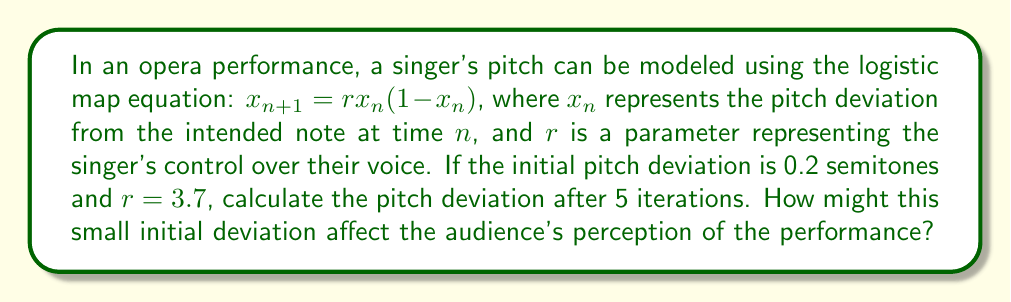What is the answer to this math problem? To solve this problem, we'll use the logistic map equation iteratively:

1) Initial conditions: $x_0 = 0.2$, $r = 3.7$

2) First iteration:
   $x_1 = 3.7 \cdot 0.2 \cdot (1-0.2) = 0.592$

3) Second iteration:
   $x_2 = 3.7 \cdot 0.592 \cdot (1-0.592) = 0.893$

4) Third iteration:
   $x_3 = 3.7 \cdot 0.893 \cdot (1-0.893) = 0.354$

5) Fourth iteration:
   $x_4 = 3.7 \cdot 0.354 \cdot (1-0.354) = 0.846$

6) Fifth iteration:
   $x_5 = 3.7 \cdot 0.846 \cdot (1-0.846) = 0.483$

The pitch deviation after 5 iterations is approximately 0.483 semitones.

This demonstrates the butterfly effect in chaos theory. A small initial deviation of 0.2 semitones leads to unpredictable fluctuations in pitch over time. These variations, while subtle, could significantly impact the audience's perception of the performance. Some listeners might perceive the singer as off-key or inconsistent, while others might interpret the variations as intentional artistic expression, depending on their musical sensitivity and expectations.
Answer: 0.483 semitones; unpredictable pitch fluctuations affecting audience perception 